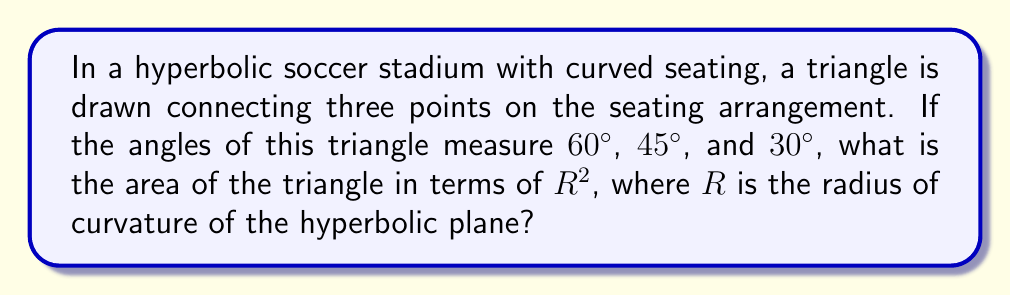What is the answer to this math problem? To solve this problem, we'll use the Gauss-Bonnet formula for hyperbolic geometry:

1) In hyperbolic geometry, the sum of angles in a triangle is less than $180°$.

2) The Gauss-Bonnet formula states that for a hyperbolic triangle:

   $$A = R^2(\pi - (\alpha + \beta + \gamma))$$

   Where $A$ is the area, $R$ is the radius of curvature, and $\alpha$, $\beta$, and $\gamma$ are the angles of the triangle in radians.

3) Convert the given angles to radians:
   $60° = \frac{\pi}{3}$
   $45° = \frac{\pi}{4}$
   $30° = \frac{\pi}{6}$

4) Sum the angles:
   $$\frac{\pi}{3} + \frac{\pi}{4} + \frac{\pi}{6} = \frac{4\pi}{12} + \frac{3\pi}{12} + \frac{2\pi}{12} = \frac{9\pi}{12} = \frac{3\pi}{4}$$

5) Substitute into the Gauss-Bonnet formula:
   $$A = R^2(\pi - \frac{3\pi}{4}) = R^2(\frac{\pi}{4})$$

6) Simplify:
   $$A = \frac{\pi R^2}{4}$$

This gives us the area of the hyperbolic triangle in terms of $R^2$.
Answer: $\frac{\pi R^2}{4}$ 